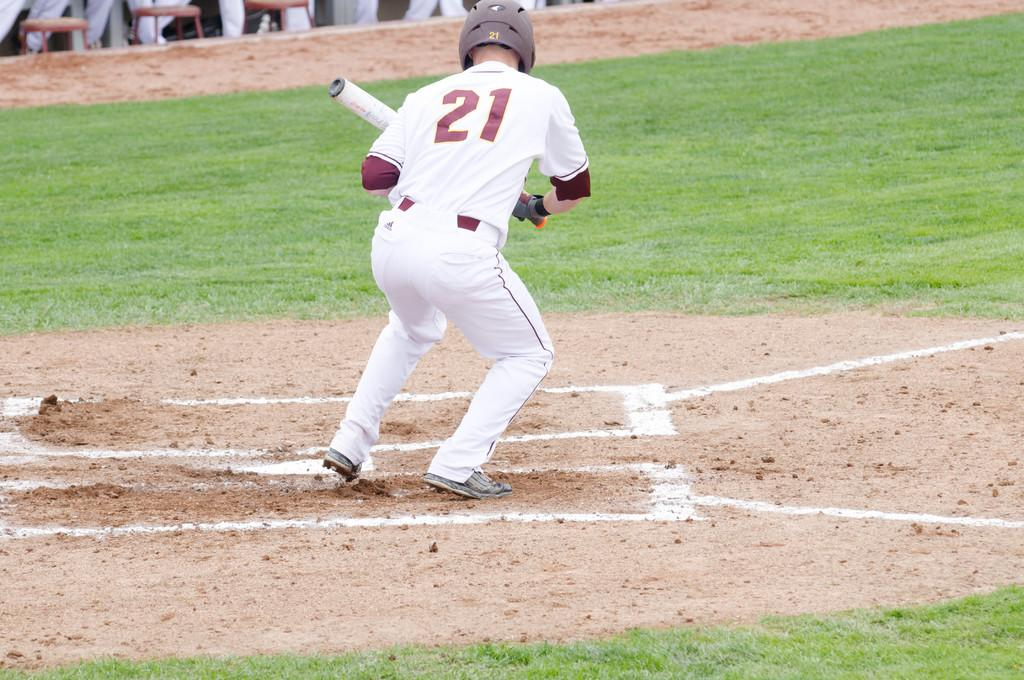<image>
Share a concise interpretation of the image provided. Number 21 is up at bat over home plate on a baseball diamond. 